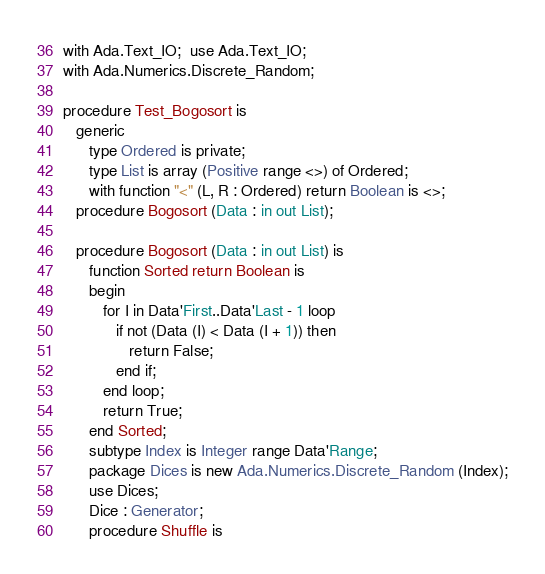<code> <loc_0><loc_0><loc_500><loc_500><_Ada_>with Ada.Text_IO;  use Ada.Text_IO;
with Ada.Numerics.Discrete_Random;

procedure Test_Bogosort is
   generic
      type Ordered is private;
      type List is array (Positive range <>) of Ordered;
      with function "<" (L, R : Ordered) return Boolean is <>;
   procedure Bogosort (Data : in out List);

   procedure Bogosort (Data : in out List) is
      function Sorted return Boolean is
      begin
         for I in Data'First..Data'Last - 1 loop
            if not (Data (I) < Data (I + 1)) then
               return False;
            end if;
         end loop;
         return True;
      end Sorted;
      subtype Index is Integer range Data'Range;
      package Dices is new Ada.Numerics.Discrete_Random (Index);
      use Dices;
      Dice : Generator;
      procedure Shuffle is</code> 